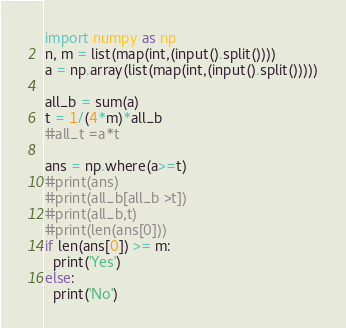<code> <loc_0><loc_0><loc_500><loc_500><_Python_>import numpy as np
n, m = list(map(int,(input().split())))
a = np.array(list(map(int,(input().split()))))

all_b = sum(a)
t = 1/(4*m)*all_b
#all_t =a*t

ans = np.where(a>=t)
#print(ans)
#print(all_b[all_b >t])
#print(all_b,t)
#print(len(ans[0]))
if len(ans[0]) >= m:
  print('Yes')
else:
  print('No')</code> 